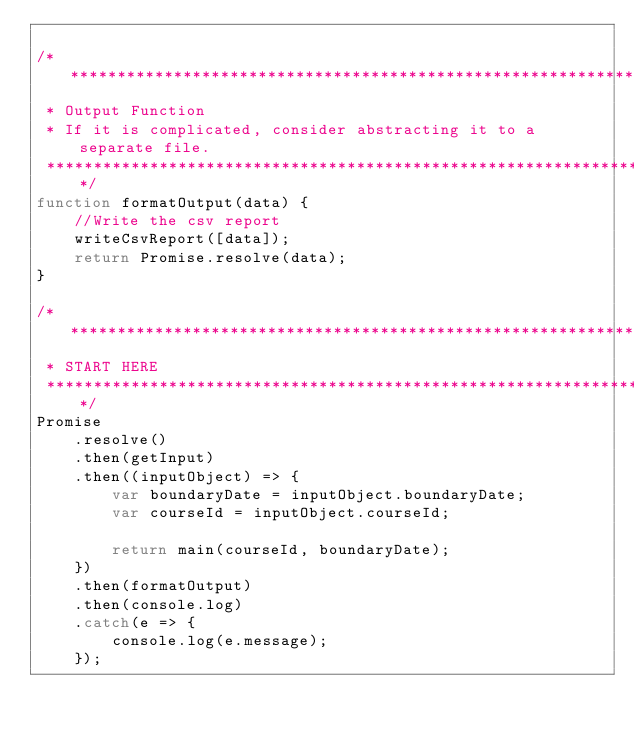Convert code to text. <code><loc_0><loc_0><loc_500><loc_500><_JavaScript_>
/************************************************************************* 
 * Output Function
 * If it is complicated, consider abstracting it to a separate file.
 *************************************************************************/
function formatOutput(data) {
    //Write the csv report
    writeCsvReport([data]);
    return Promise.resolve(data);
}

/************************************************************************* 
 * START HERE
 *************************************************************************/
Promise
    .resolve()
    .then(getInput)
    .then((inputObject) => {
        var boundaryDate = inputObject.boundaryDate;
        var courseId = inputObject.courseId;

        return main(courseId, boundaryDate);
    })
    .then(formatOutput)
    .then(console.log)
    .catch(e => {
        console.log(e.message);
    });</code> 